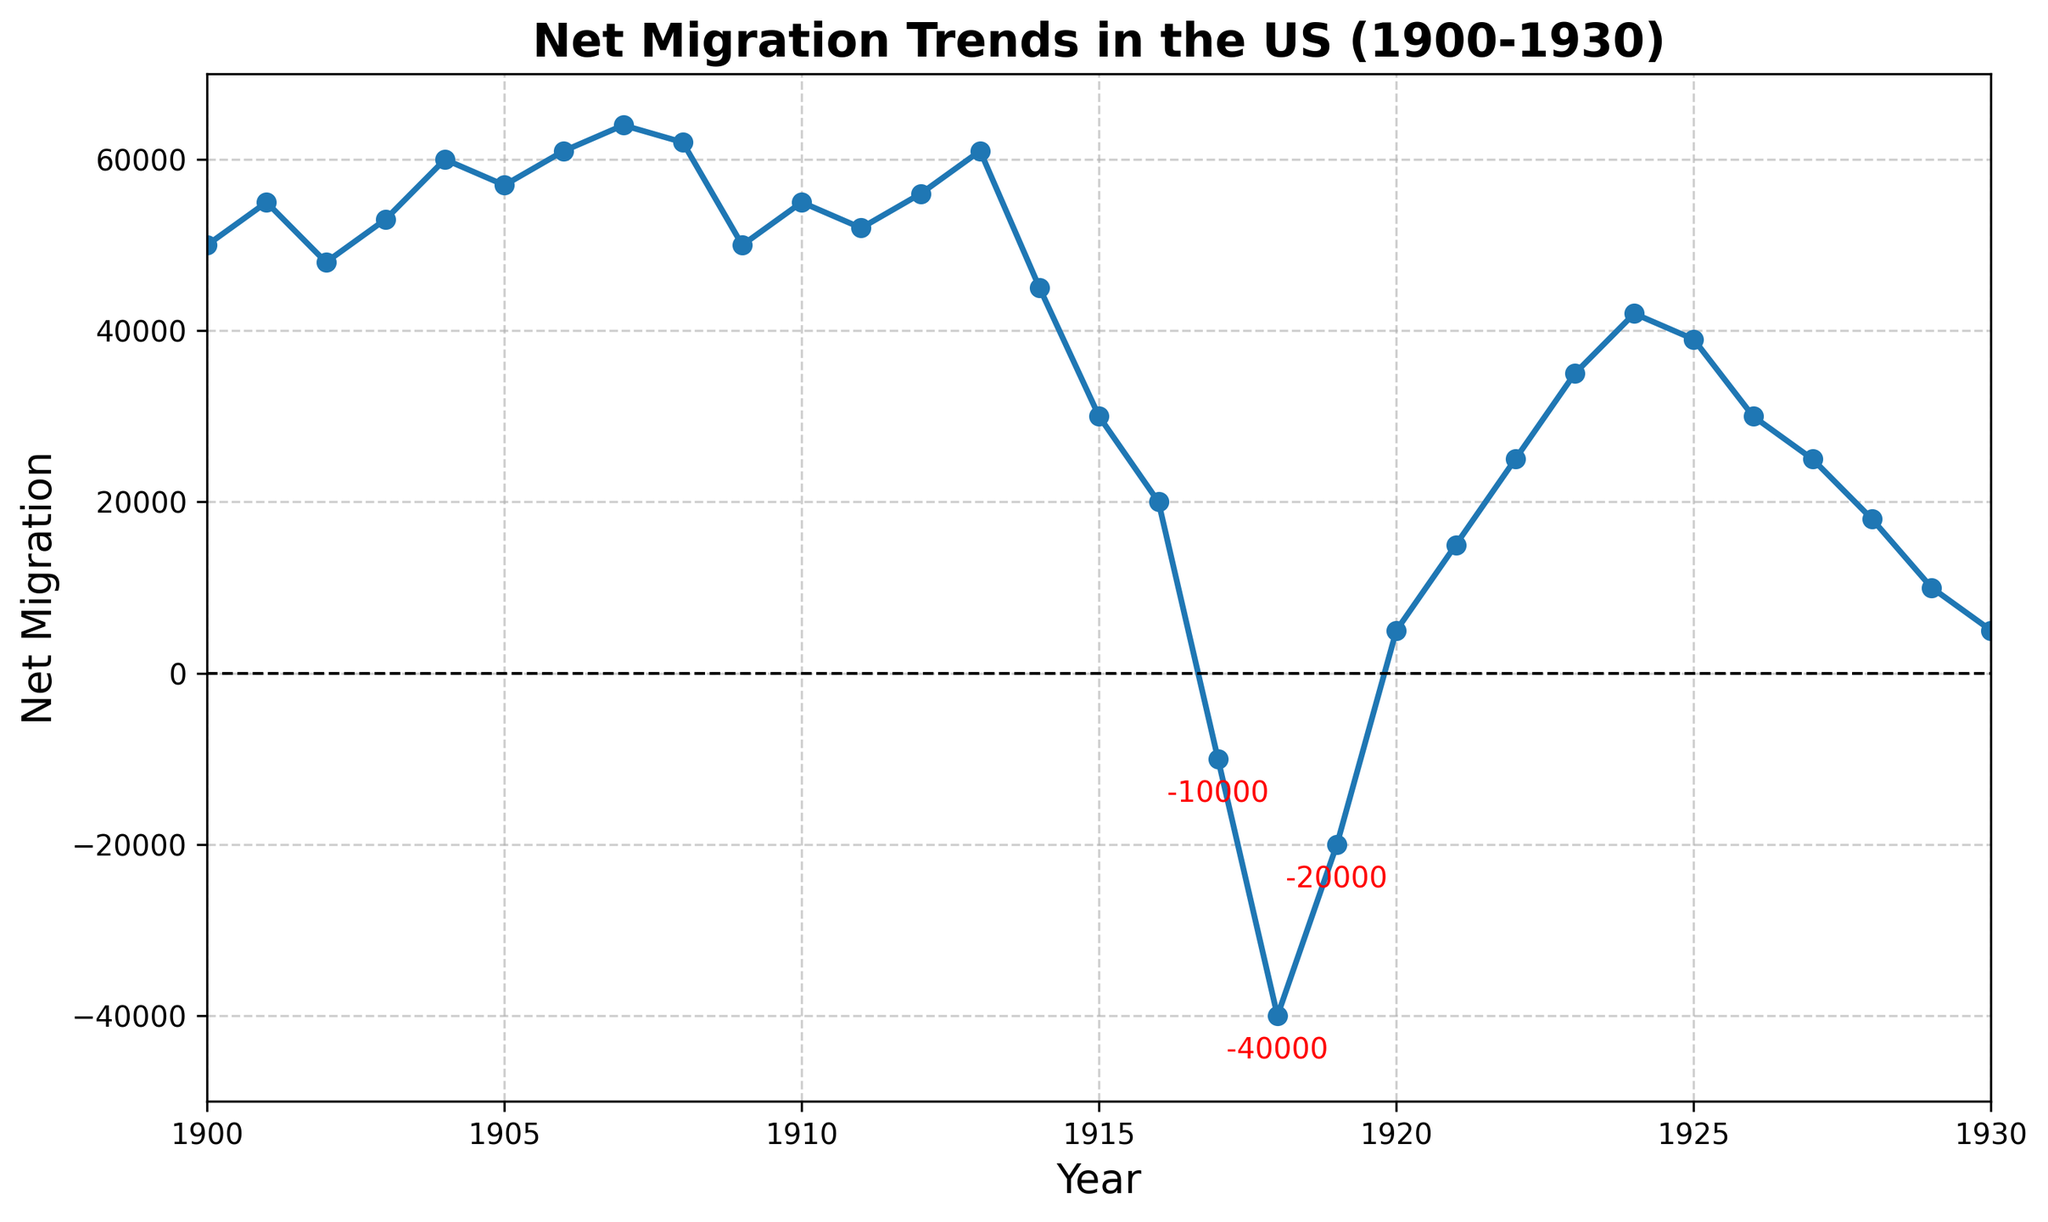What year had the highest net migration value? The highest net migration value is shown at the peak of the line, which corresponds to the year 1907 with a value of 64,000.
Answer: 1907 Which years had negative net migration values? Negative net migration values are those below the horizontal line at y=0. The corresponding years are 1917 (-10,000), 1918 (-40,000), and 1919 (-20,000).
Answer: 1917, 1918, 1919 During which period did the net migration drop most dramatically? The most dramatic drop in net migration is shown by the steepest downward slope, which occurred between 1914 (45,000) and 1918 (-40,000).
Answer: 1914-1918 Compare the net migration values of 1920 and 1930. Which year had a higher value and by how much? Net migration in 1920 is 5,000, and in 1930 is also 5,000. Therefore, both years had the same value.
Answer: Equal How many years had a net migration value greater than 50,000? Years with net migration values above 50,000 can be counted: 1900, 1901, 1903, 1904, 1905, 1906, 1907, 1908, 1910, 1911, 1912, 1913, and 1914. There are 13 such years.
Answer: 13 What is the net migration value in 1918 and how does it compare to the value in 1917? In 1918, the net migration value is -40,000, and in 1917, it is -10,000. The value in 1918 is 30,000 less than in 1917.
Answer: 1918 had a net migration value of -40,000, which is 30,000 less than 1917 How much did the net migration value change from 1900 (50,000) to 1910 (55,000)? Subtract the net migration value of 1900 from 1910: 55,000 - 50,000 = 5,000.
Answer: It increased by 5,000 Which year shows the first instance of negative net migration value? The first instance where the line drops below the y=0 line occurs in 1917.
Answer: 1917 